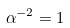Convert formula to latex. <formula><loc_0><loc_0><loc_500><loc_500>\alpha ^ { - 2 } = 1</formula> 